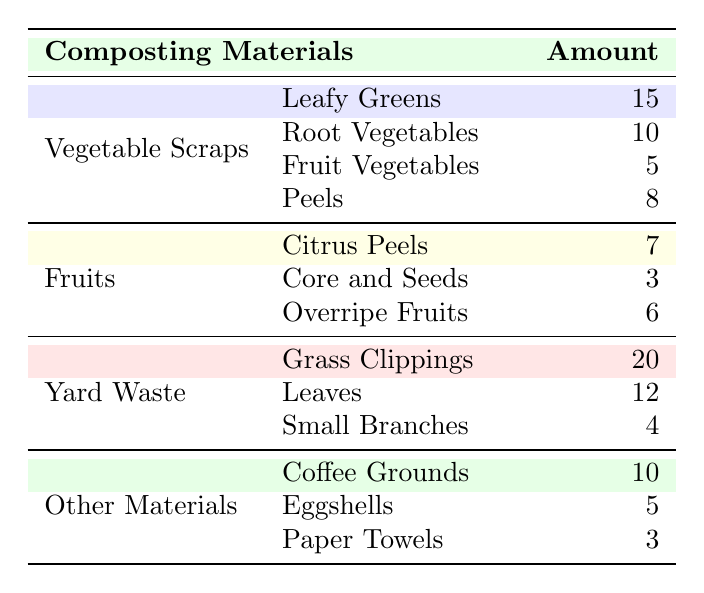What is the total amount of Vegetable Scraps collected? To find the total amount of Vegetable Scraps, we sum the individual categories: Leafy Greens (15) + Root Vegetables (10) + Fruit Vegetables (5) + Peels (8). The calculation is 15 + 10 + 5 + 8 = 38.
Answer: 38 How many more Grass Clippings are there than Small Branches? To find the difference between Grass Clippings and Small Branches, we subtract the amount of Small Branches (4) from Grass Clippings (20). The calculation is 20 - 4 = 16.
Answer: 16 Is there more total Yard Waste or total Fruits collected? We calculate the total for Yard Waste: Grass Clippings (20) + Leaves (12) + Small Branches (4) = 36. Then for Fruits: Citrus Peels (7) + Core and Seeds (3) + Overripe Fruits (6) = 16. Since 36 (Yard Waste) is greater than 16 (Fruits), the answer is yes.
Answer: Yes Which category has the least amount of collected materials? We compare the totals of each category: Vegetable Scraps (38), Fruits (16), Yard Waste (36), Other Materials (18). The smallest total is 16 from Fruits.
Answer: Fruits What is the average amount of Other Materials collected? For Other Materials, we have three data points: Coffee Grounds (10), Eggshells (5), and Paper Towels (3). We calculate the sum as 10 + 5 + 3 = 18 and then divide by the number of items (3) to find the average: 18 / 3 = 6.
Answer: 6 How many total materials are collected from Peels, Core and Seeds, and Leaves? To find the total, we add the amounts from the specified categories: Peels (8), Core and Seeds (3), and Leaves (12). The calculation is 8 + 3 + 12 = 23.
Answer: 23 Are there more Coffee Grounds collected than Overripe Fruits? We compare the amounts: Coffee Grounds (10) and Overripe Fruits (6). Since 10 is greater than 6, the answer is yes.
Answer: Yes What is the combined total of all composting materials? To find the combined total, we add all values: 15 + 10 + 5 + 8 (Vegetable Scraps) + 7 + 3 + 6 (Fruits) + 20 + 12 + 4 (Yard Waste) + 10 + 5 + 3 (Other Materials). The total is 15 + 10 + 5 + 8 + 7 + 3 + 6 + 20 + 12 + 4 + 10 + 5 + 3 =  102.
Answer: 102 